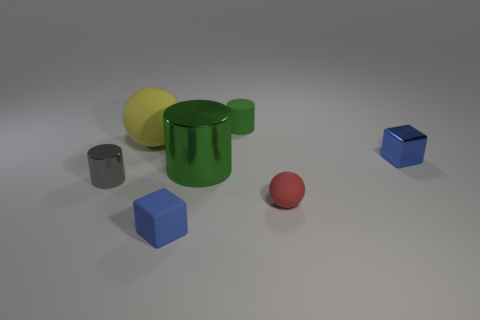Subtract all green rubber cylinders. How many cylinders are left? 2 Add 2 tiny metal cylinders. How many objects exist? 9 Subtract all gray cylinders. How many cylinders are left? 2 Subtract all purple cylinders. How many yellow balls are left? 1 Subtract 0 cyan balls. How many objects are left? 7 Subtract all blocks. How many objects are left? 5 Subtract 3 cylinders. How many cylinders are left? 0 Subtract all red cylinders. Subtract all green balls. How many cylinders are left? 3 Subtract all big yellow rubber things. Subtract all large cylinders. How many objects are left? 5 Add 2 metal things. How many metal things are left? 5 